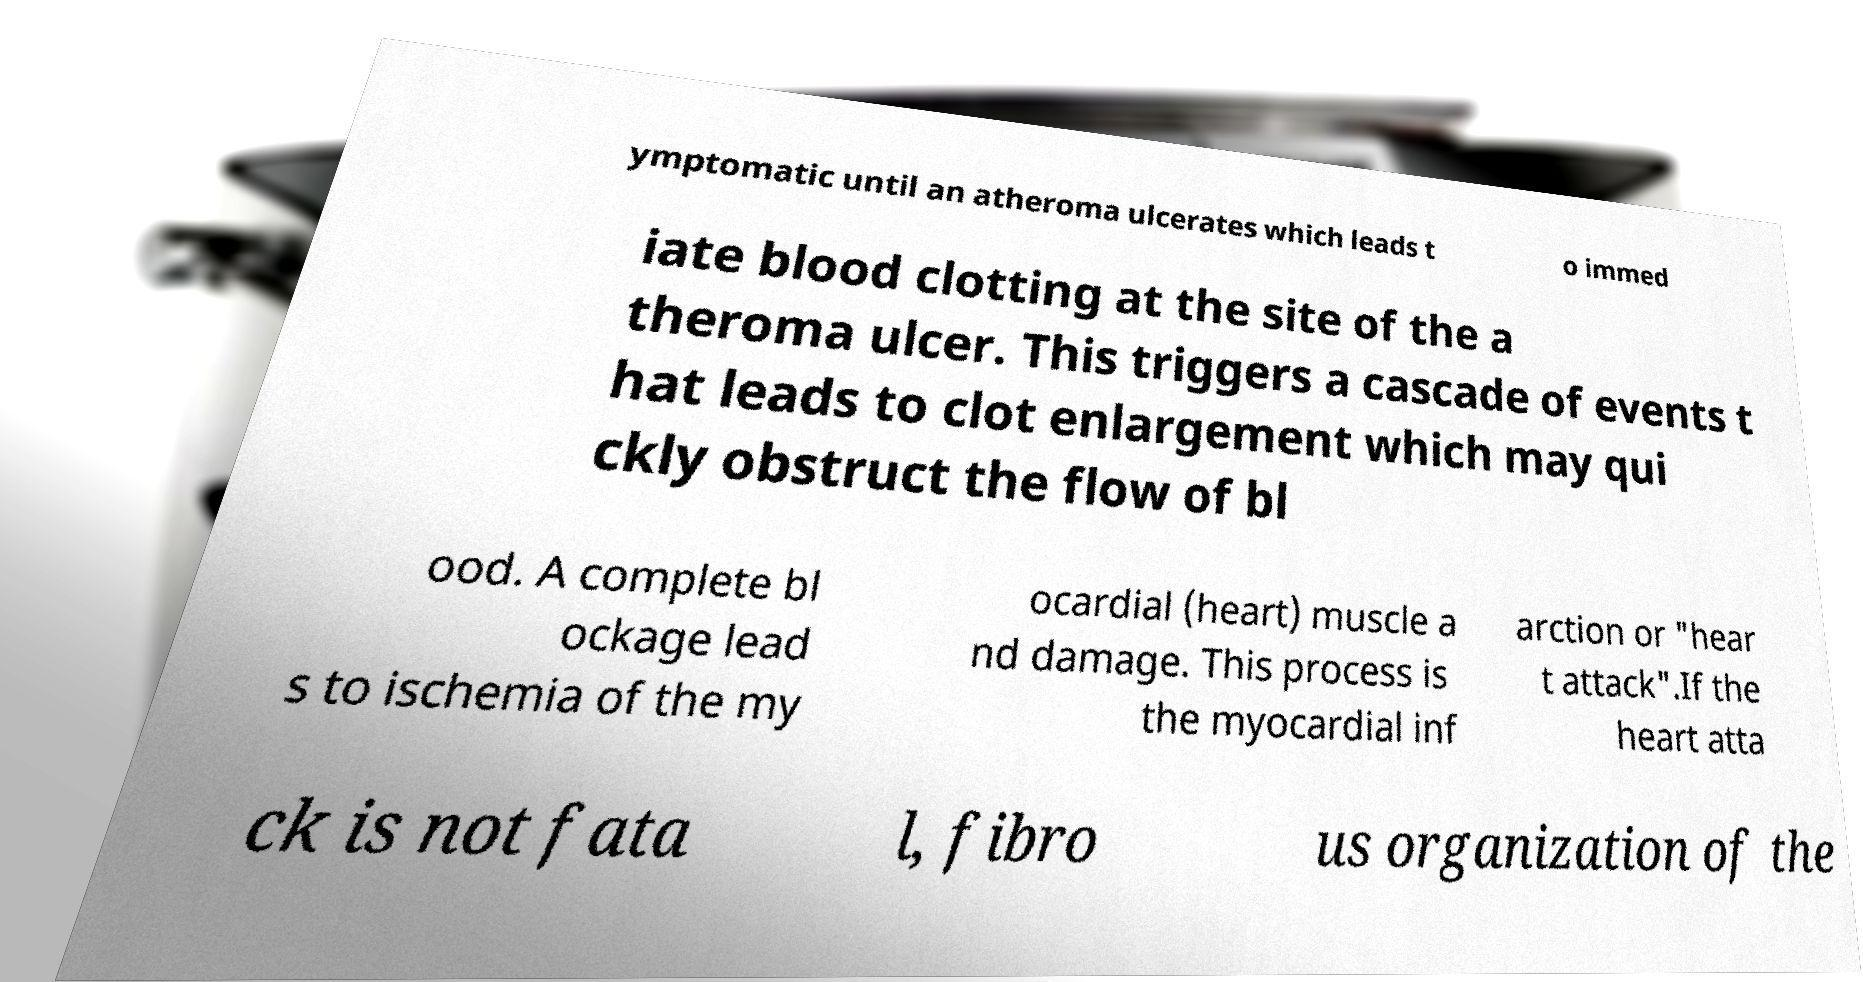Could you assist in decoding the text presented in this image and type it out clearly? ymptomatic until an atheroma ulcerates which leads t o immed iate blood clotting at the site of the a theroma ulcer. This triggers a cascade of events t hat leads to clot enlargement which may qui ckly obstruct the flow of bl ood. A complete bl ockage lead s to ischemia of the my ocardial (heart) muscle a nd damage. This process is the myocardial inf arction or "hear t attack".If the heart atta ck is not fata l, fibro us organization of the 